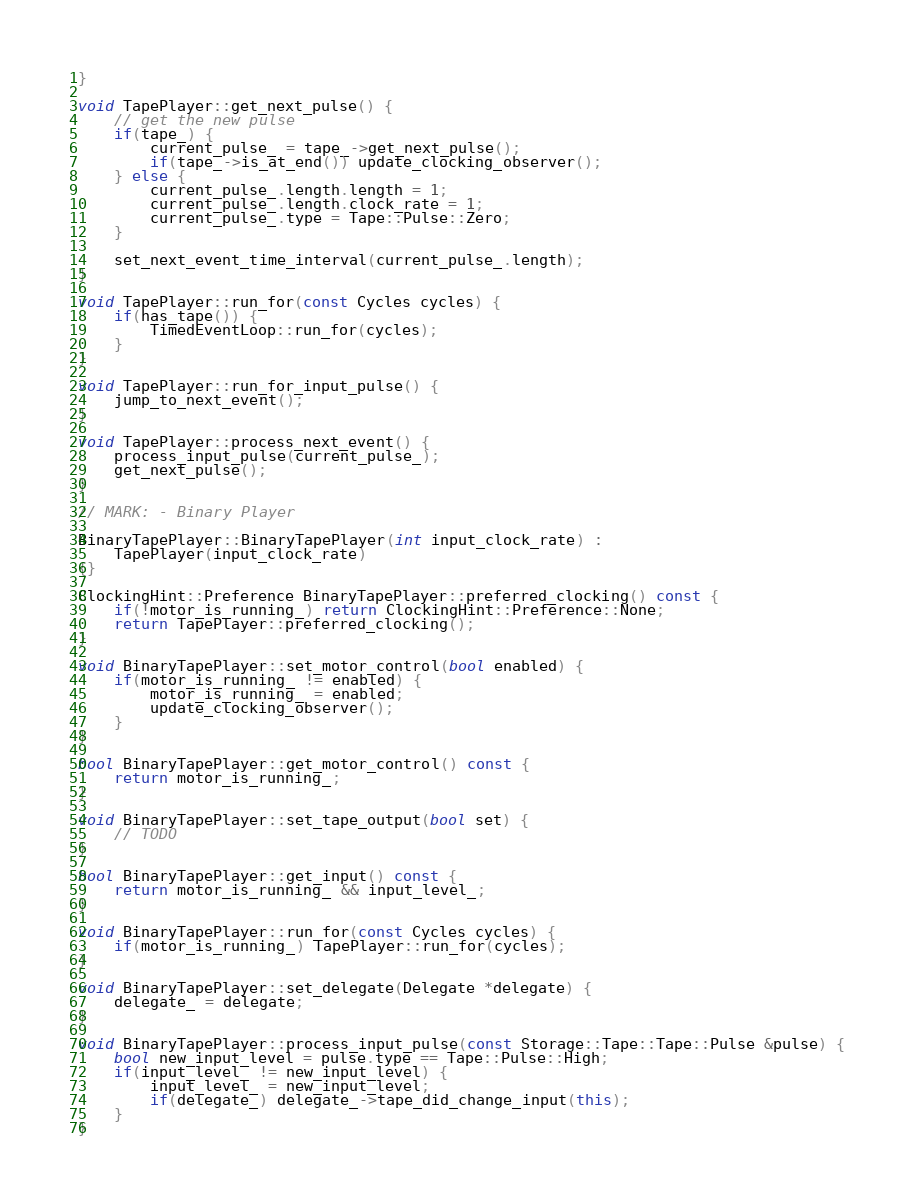<code> <loc_0><loc_0><loc_500><loc_500><_C++_>}

void TapePlayer::get_next_pulse() {
	// get the new pulse
	if(tape_) {
		current_pulse_ = tape_->get_next_pulse();
		if(tape_->is_at_end()) update_clocking_observer();
	} else {
		current_pulse_.length.length = 1;
		current_pulse_.length.clock_rate = 1;
		current_pulse_.type = Tape::Pulse::Zero;
	}

	set_next_event_time_interval(current_pulse_.length);
}

void TapePlayer::run_for(const Cycles cycles) {
	if(has_tape()) {
		TimedEventLoop::run_for(cycles);
	}
}

void TapePlayer::run_for_input_pulse() {
	jump_to_next_event();
}

void TapePlayer::process_next_event() {
	process_input_pulse(current_pulse_);
	get_next_pulse();
}

// MARK: - Binary Player

BinaryTapePlayer::BinaryTapePlayer(int input_clock_rate) :
	TapePlayer(input_clock_rate)
{}

ClockingHint::Preference BinaryTapePlayer::preferred_clocking() const {
	if(!motor_is_running_) return ClockingHint::Preference::None;
	return TapePlayer::preferred_clocking();
}

void BinaryTapePlayer::set_motor_control(bool enabled) {
	if(motor_is_running_ != enabled) {
		motor_is_running_ = enabled;
		update_clocking_observer();
	}
}

bool BinaryTapePlayer::get_motor_control() const {
	return motor_is_running_;
}

void BinaryTapePlayer::set_tape_output(bool set) {
	// TODO
}

bool BinaryTapePlayer::get_input() const {
	return motor_is_running_ && input_level_;
}

void BinaryTapePlayer::run_for(const Cycles cycles) {
	if(motor_is_running_) TapePlayer::run_for(cycles);
}

void BinaryTapePlayer::set_delegate(Delegate *delegate) {
	delegate_ = delegate;
}

void BinaryTapePlayer::process_input_pulse(const Storage::Tape::Tape::Pulse &pulse) {
	bool new_input_level = pulse.type == Tape::Pulse::High;
	if(input_level_ != new_input_level) {
		input_level_ = new_input_level;
		if(delegate_) delegate_->tape_did_change_input(this);
	}
}
</code> 